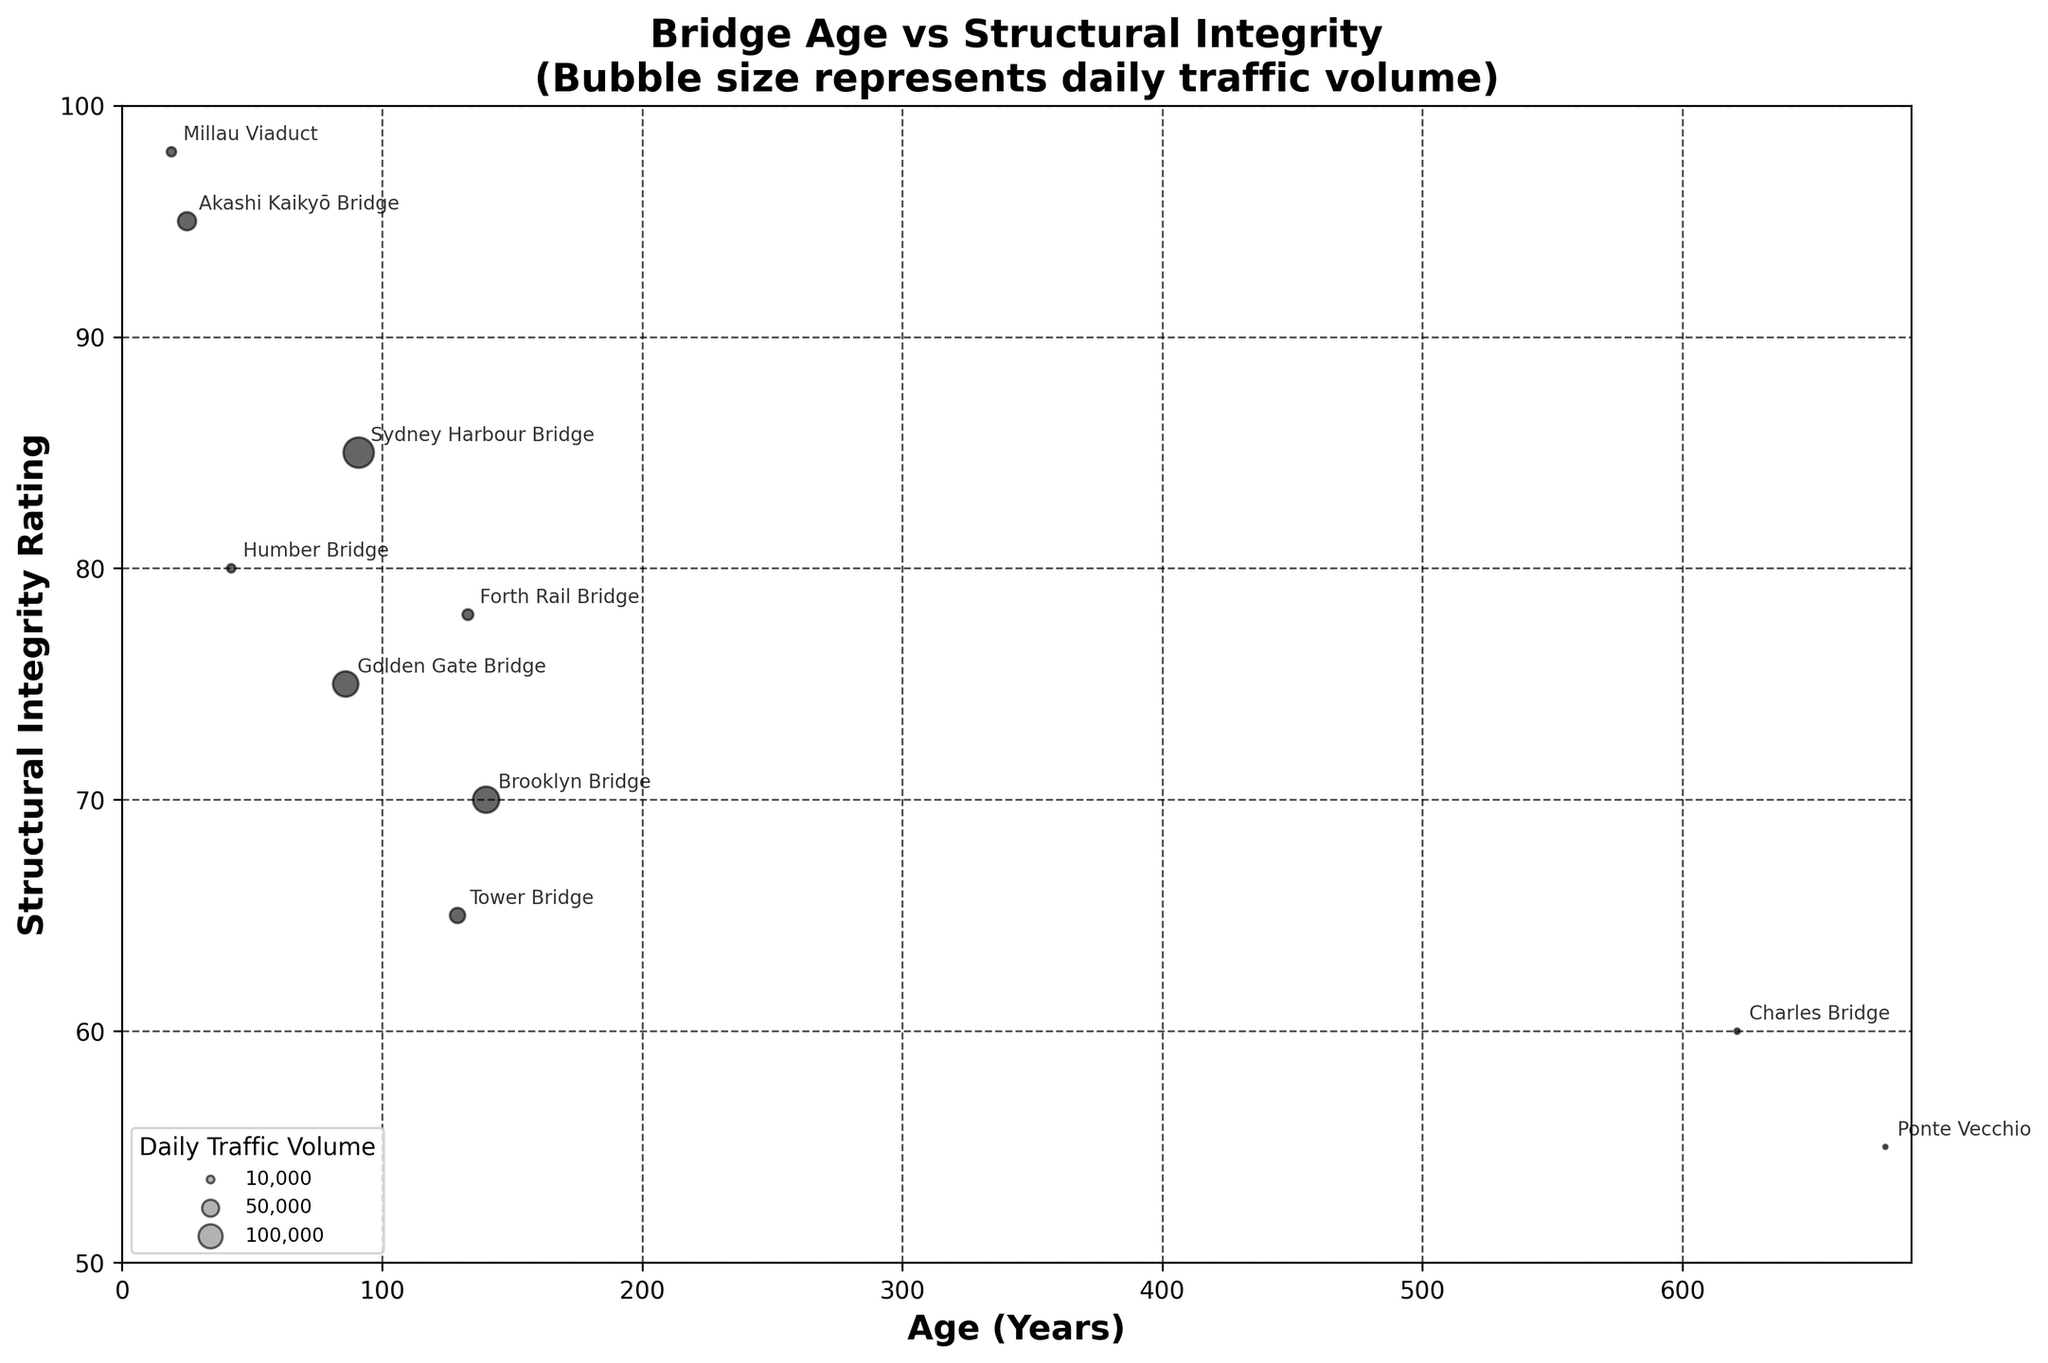What is the title of the chart? The title is typically placed at the top center of the chart to give an overview of what the chart is about. Here, it describes the relationship between the age and structural integrity of bridges, along with the representation of daily traffic volume.
Answer: Bridge Age vs Structural Integrity (Bubble size represents daily traffic volume) How many bridges are depicted in the chart? Each bridge is represented by a bubble in the chart. Counting the number of bubbles or checking the labels beside each bubble will give you the total number of bridges.
Answer: 10 Which bridge has the highest structural integrity rating? On the chart, the structural integrity rating is on the y-axis. The highest point on the y-axis will correspond to the bridge with the highest rating.
Answer: Millau Viaduct Which bridge is the oldest? The age of the bridge is indicated on the x-axis, with the furthest point to the right indicating the oldest bridge.
Answer: Charles Bridge What is the average structural integrity rating of all bridges? To find the average, sum the structural integrity ratings of all bridges and divide by the number of bridges. Sum = 75 + 65 + 85 + 70 + 95 + 98 + 60 + 80 + 55 + 78 = 761. Average = 761 / 10.
Answer: 76.1 Which bridge has the largest daily traffic volume? The size of the bubble represents the daily traffic volume. The largest bubble on the chart indicates the bridge with the highest traffic volume.
Answer: Sydney Harbour Bridge What is the difference in structural integrity rating between the newest and the oldest bridge? Identify the newest and oldest bridges from the x-axis, then find their corresponding y-axis values and subtract the integrity rating of the oldest from the newest. Newest = Millau Viaduct (98), Oldest = Charles Bridge (60). Difference = 98 - 60.
Answer: 38 Are there any bridges with a structural integrity rating of exactly 70? If so, name them. Locate the y-axis value of 70 and see if any bubbles align with this value.
Answer: Brooklyn Bridge Compare the traffic volume of the Golden Gate Bridge and the Akashi Kaikyō Bridge. Which one has higher traffic volume and by how much? Look at the size of the bubbles for both bridges. Golden Gate Bridge = 112000, Akashi Kaikyō Bridge = 57000. Difference = 112000 - 57000.
Answer: Golden Gate Bridge by 55000 What is the trend observed between bridge age and structural integrity? Examine the scatter plot for any visible pattern. Generally, as the bridge age increases (moving right along the x-axis), the structural integrity rating appears to decrease (lower points on the y-axis).
Answer: Older bridges tend to have lower structural integrity ratings 